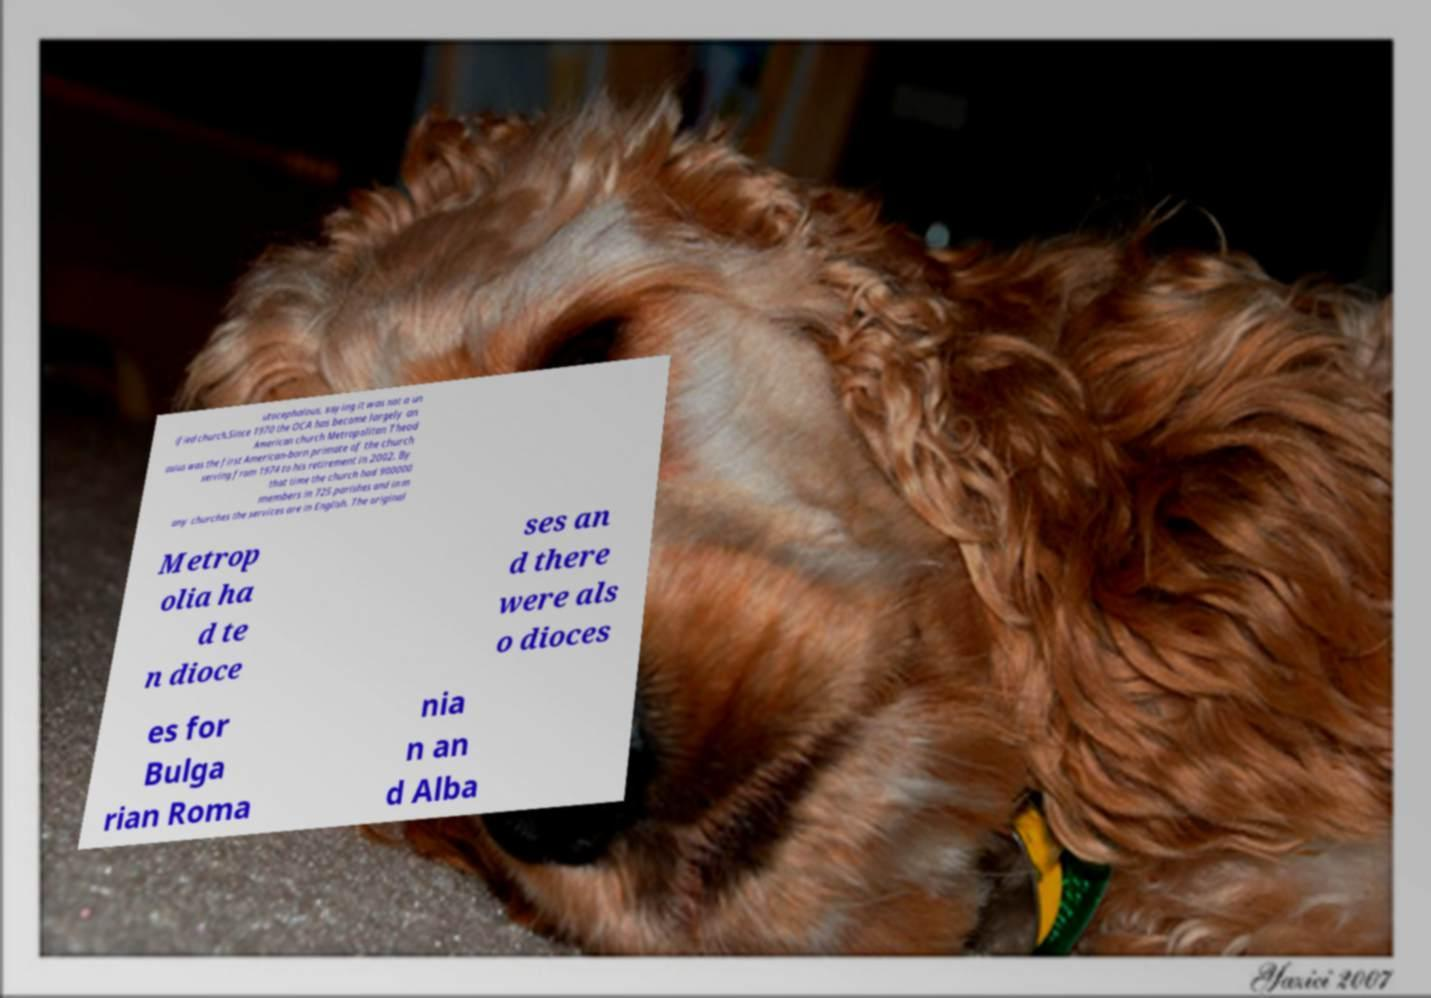There's text embedded in this image that I need extracted. Can you transcribe it verbatim? utocephalous, saying it was not a un ified church.Since 1970 the OCA has become largely an American church Metropolitan Theod osius was the first American-born primate of the church serving from 1974 to his retirement in 2002. By that time the church had 900000 members in 725 parishes and in m any churches the services are in English. The original Metrop olia ha d te n dioce ses an d there were als o dioces es for Bulga rian Roma nia n an d Alba 